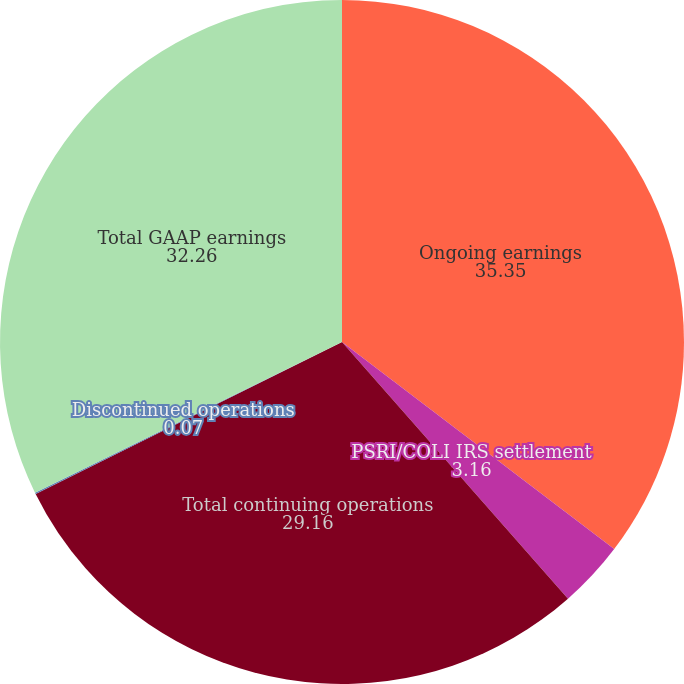Convert chart to OTSL. <chart><loc_0><loc_0><loc_500><loc_500><pie_chart><fcel>Ongoing earnings<fcel>PSRI/COLI IRS settlement<fcel>Total continuing operations<fcel>Discontinued operations<fcel>Total GAAP earnings<nl><fcel>35.35%<fcel>3.16%<fcel>29.16%<fcel>0.07%<fcel>32.26%<nl></chart> 